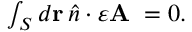<formula> <loc_0><loc_0><loc_500><loc_500>\begin{array} { r } { \int _ { S } d r \, \hat { n } \cdot \varepsilon A \, = 0 . } \end{array}</formula> 